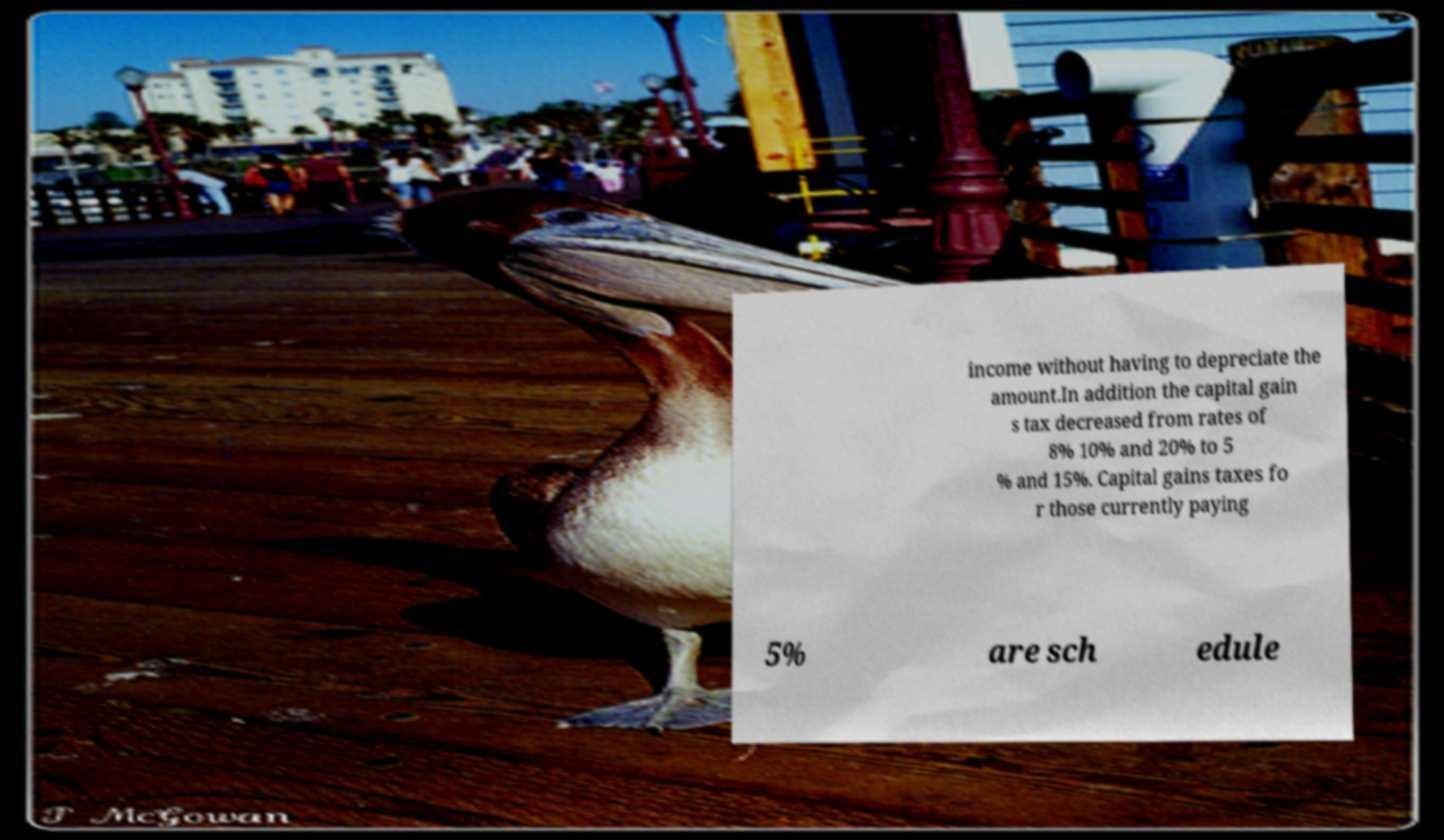Could you assist in decoding the text presented in this image and type it out clearly? income without having to depreciate the amount.In addition the capital gain s tax decreased from rates of 8% 10% and 20% to 5 % and 15%. Capital gains taxes fo r those currently paying 5% are sch edule 